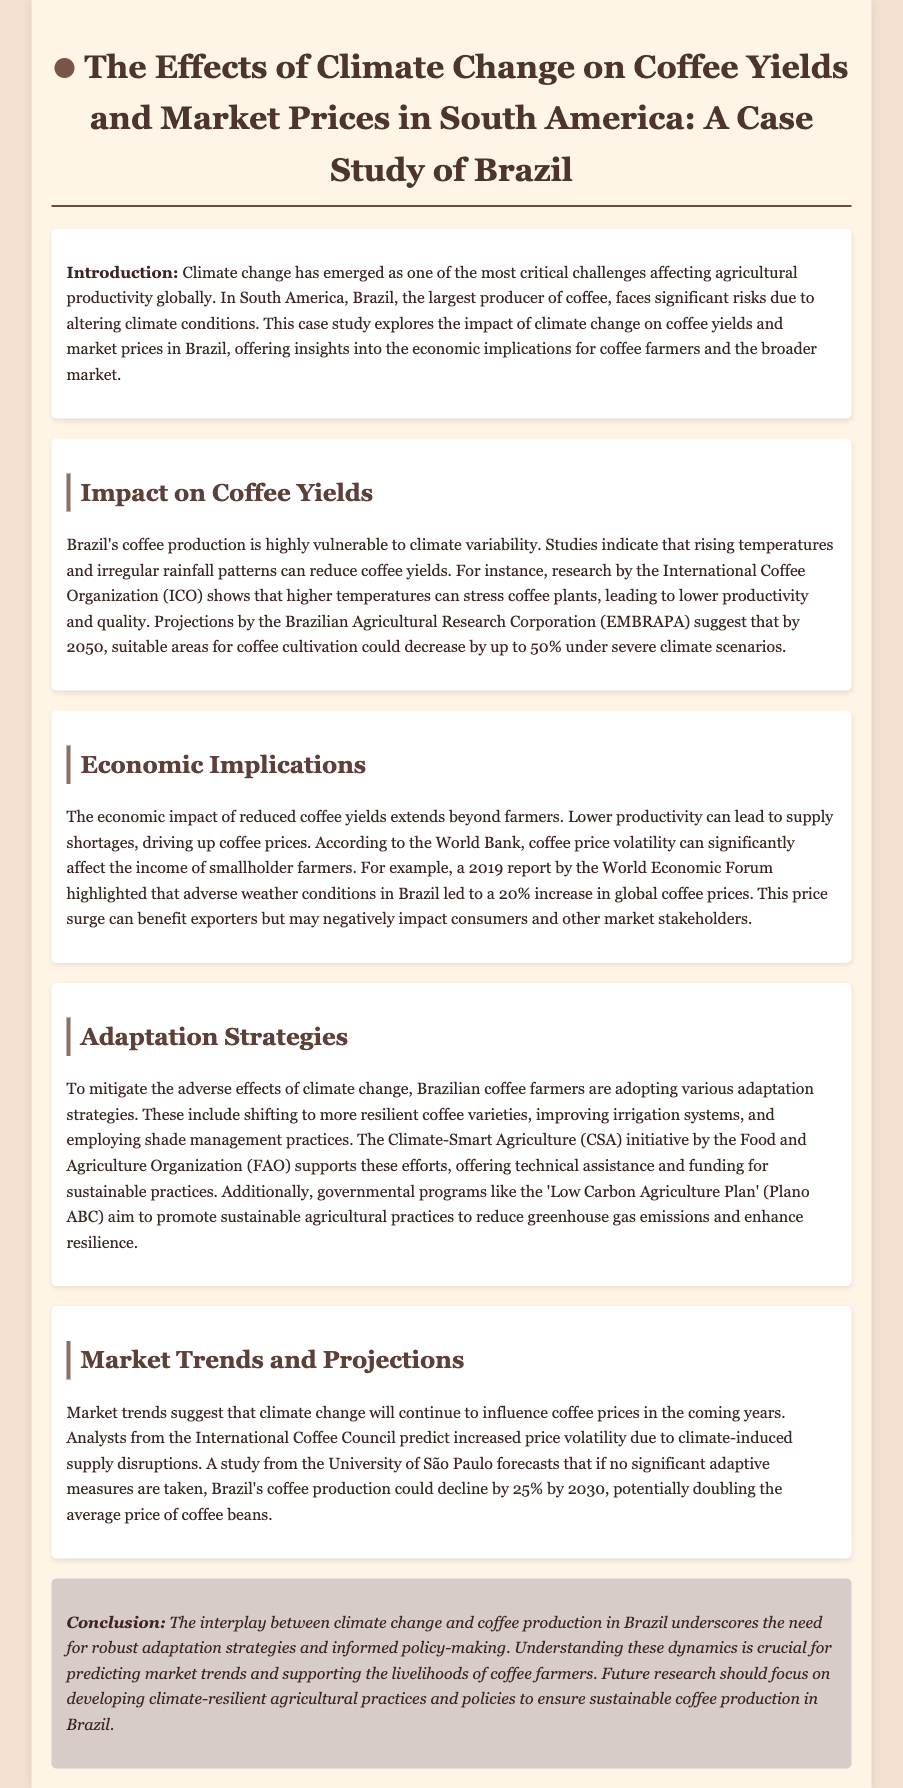What is the primary agricultural product discussed? The document discusses the impact of climate change on coffee production, specifically in Brazil.
Answer: Coffee Which organization conducted research showing the impact of higher temperatures on coffee plants? The International Coffee Organization (ICO) is mentioned as having conducted relevant research.
Answer: ICO By what percentage could suitable areas for coffee cultivation decrease by 2050? Projections suggest that suitable areas for coffee cultivation could decrease by up to 50% under severe climate scenarios by 2050.
Answer: 50% What was the increase in global coffee prices due to adverse weather conditions in Brazil in 2019? The World Economic Forum report indicated a significant increase in global coffee prices, specifically a 20% rise due to adverse weather.
Answer: 20% What initiative supports adaptation strategies for Brazilian coffee farmers? The Climate-Smart Agriculture (CSA) initiative by the Food and Agriculture Organization (FAO) is mentioned as supporting farmers.
Answer: CSA What is the predicted decline percentage in Brazil's coffee production by 2030 without significant adaptive measures? A study forecasts a decline of 25% in Brazil's coffee production by 2030 if no significant adaptive measures are taken.
Answer: 25% What government program aims to promote sustainable agricultural practices in Brazil? The 'Low Carbon Agriculture Plan' (Plano ABC) is cited as a government program supporting sustainable agriculture.
Answer: Plano ABC What should future research focus on regarding coffee production? The document concludes that future research should focus on developing climate-resilient agricultural practices and policies.
Answer: Climate-resilient agricultural practices 